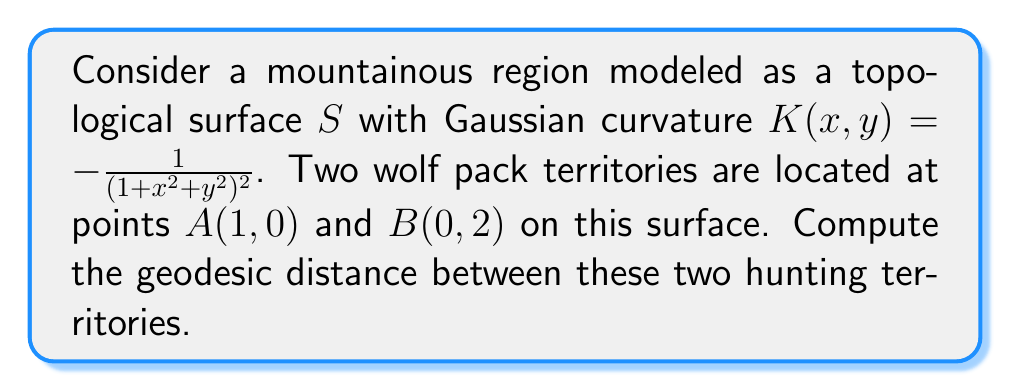Give your solution to this math problem. To solve this problem, we need to follow these steps:

1) First, recall that for a surface with a metric $ds^2 = E dx^2 + 2F dx dy + G dy^2$, the geodesic distance between two points is given by:

   $$L = \int_0^1 \sqrt{E(\dot{x})^2 + 2F\dot{x}\dot{y} + G(\dot{y})^2} dt$$

   where $x(t)$ and $y(t)$ parametrize the geodesic path.

2) For our surface with the given Gaussian curvature, we can derive that the metric is:

   $$ds^2 = (1+x^2+y^2)(dx^2 + dy^2)$$

   So, $E = G = 1+x^2+y^2$ and $F = 0$.

3) The geodesic equation for this metric is:

   $$\ddot{x} + \frac{x}{1+x^2+y^2}(\dot{x}^2-\dot{y}^2) + \frac{2xy}{1+x^2+y^2}\dot{x}\dot{y} = 0$$
   $$\ddot{y} + \frac{y}{1+x^2+y^2}(\dot{y}^2-\dot{x}^2) + \frac{2xy}{1+x^2+y^2}\dot{x}\dot{y} = 0$$

4) Solving these equations analytically is challenging. However, we can use the fact that the shortest path between two points on this surface lies on a great circle of the stereographic projection of the surface onto a sphere.

5) The stereographic projection of points $A(1,0)$ and $B(0,2)$ onto the unit sphere are:

   $A': (\frac{2}{3}, 0, \frac{1}{3})$ and $B': (0, \frac{4}{5}, \frac{3}{5})$

6) The angle $\theta$ between these vectors is:

   $$\cos \theta = \frac{2}{3} \cdot 0 + 0 \cdot \frac{4}{5} + \frac{1}{3} \cdot \frac{3}{5} = \frac{1}{5}$$

   $$\theta = \arccos(\frac{1}{5}) \approx 1.3694$$

7) The geodesic distance on the original surface is then:

   $$L = 2 \arcsinh(\frac{\tan(\theta/2)}{\sqrt{2}})$$

8) Substituting the value of $\theta$:

   $$L = 2 \arcsinh(\frac{\tan(0.6847)}{\sqrt{2}}) \approx 1.7627$$
Answer: The geodesic distance between the two hunting territories is approximately 1.7627 units. 